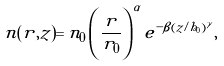<formula> <loc_0><loc_0><loc_500><loc_500>n ( r , z ) = n _ { 0 } \left ( \frac { r } { r _ { 0 } } \right ) ^ { \alpha } e ^ { - \beta ( z / h _ { 0 } ) ^ { \gamma } } ,</formula> 